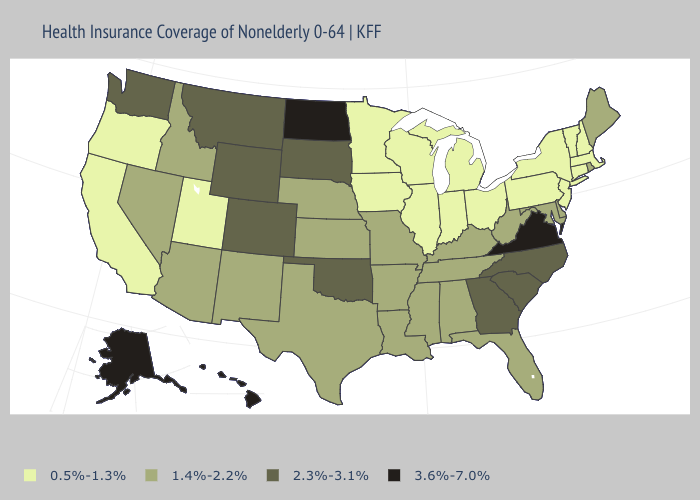What is the lowest value in states that border Colorado?
Write a very short answer. 0.5%-1.3%. What is the value of Hawaii?
Concise answer only. 3.6%-7.0%. Does Louisiana have a higher value than Montana?
Give a very brief answer. No. Is the legend a continuous bar?
Quick response, please. No. Which states have the lowest value in the USA?
Answer briefly. California, Connecticut, Illinois, Indiana, Iowa, Massachusetts, Michigan, Minnesota, New Hampshire, New Jersey, New York, Ohio, Oregon, Pennsylvania, Utah, Vermont, Wisconsin. Does Michigan have the highest value in the MidWest?
Quick response, please. No. What is the lowest value in the USA?
Short answer required. 0.5%-1.3%. Which states have the lowest value in the USA?
Keep it brief. California, Connecticut, Illinois, Indiana, Iowa, Massachusetts, Michigan, Minnesota, New Hampshire, New Jersey, New York, Ohio, Oregon, Pennsylvania, Utah, Vermont, Wisconsin. What is the value of New Hampshire?
Be succinct. 0.5%-1.3%. Does Iowa have a lower value than California?
Keep it brief. No. How many symbols are there in the legend?
Be succinct. 4. Which states have the lowest value in the West?
Be succinct. California, Oregon, Utah. What is the lowest value in states that border Wisconsin?
Write a very short answer. 0.5%-1.3%. What is the value of Rhode Island?
Short answer required. 1.4%-2.2%. Name the states that have a value in the range 3.6%-7.0%?
Keep it brief. Alaska, Hawaii, North Dakota, Virginia. 